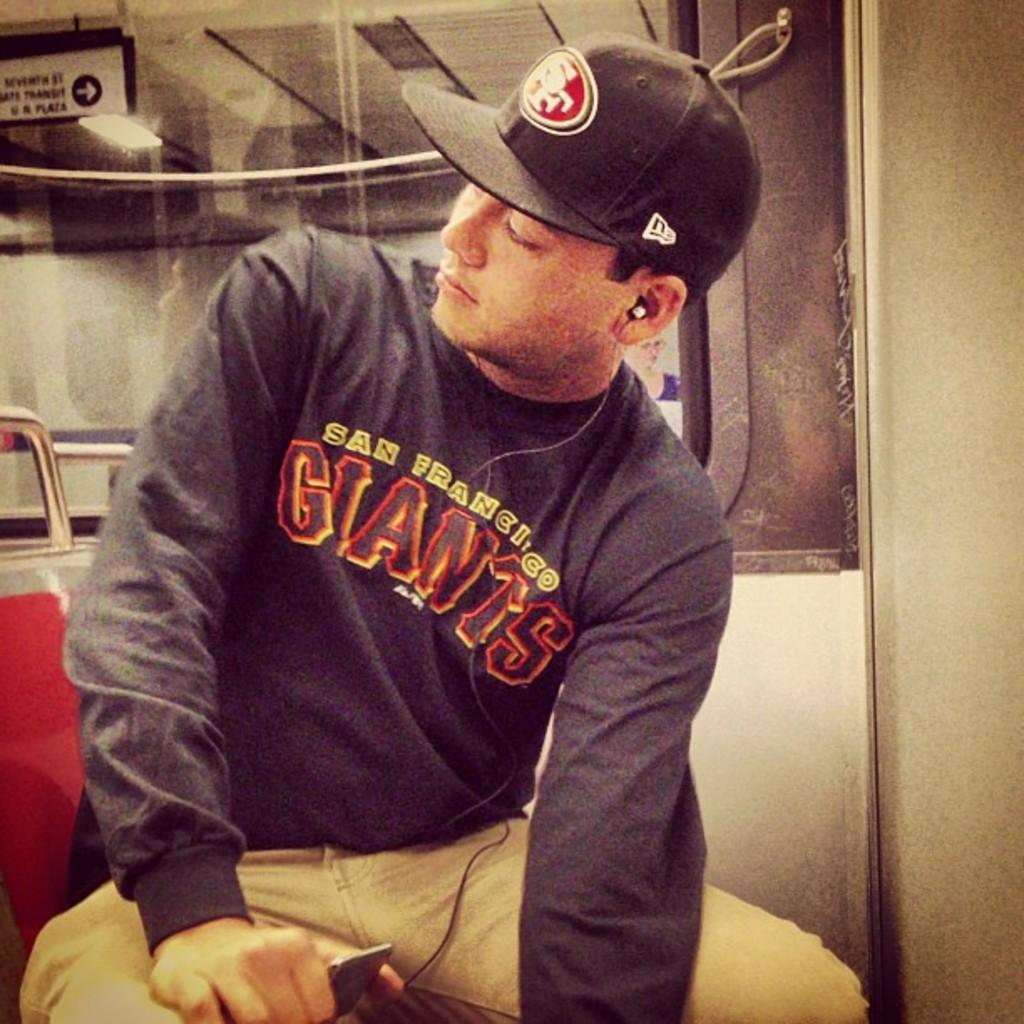<image>
Write a terse but informative summary of the picture. A man wearing a San Fansisco Giants shirt and hat. 